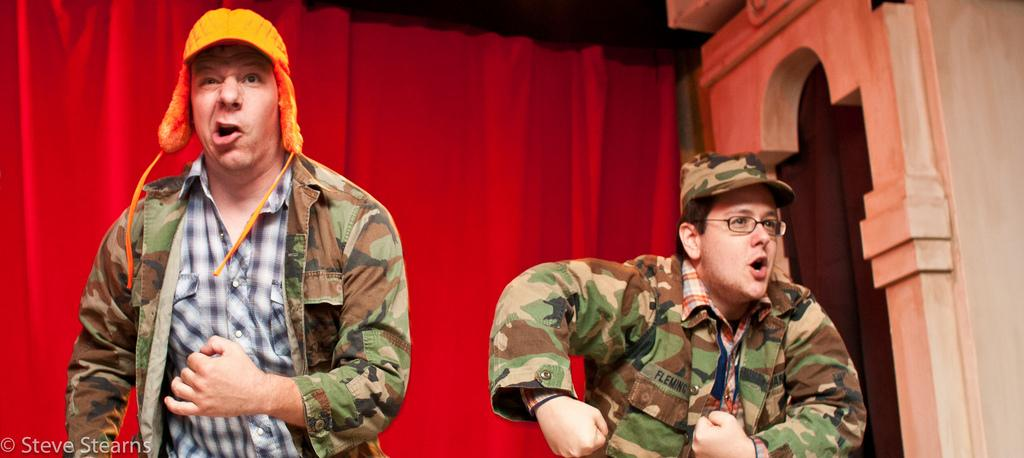How many individuals are present in the image? There are two people in the image. What can be seen behind the people? There are curtains behind the people. What is located on the left side of the image? There is some text on the left side of the image. What is on the right side of the image? There is a wall on the right side of the image. What type of creature is depicted in the text on the left side of the image? There is no creature depicted in the text on the left side of the image. What is the desire of the people in the image? The facts provided do not give any information about the desires of the people in the image. 